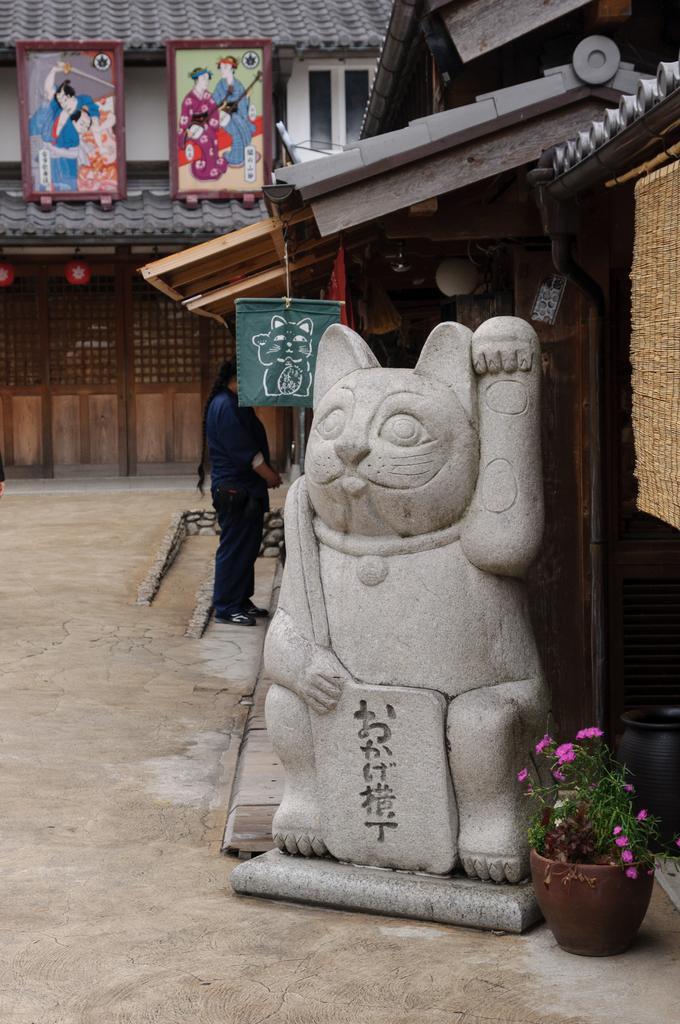Please provide a concise description of this image. This picture is clicked outside. On the right there is a sculpture of an animal and a houseplant placed on the ground and a person standing on the ground. In the background we can see the buildings and posters hanging on the roof on which we can see the pictures of some persons. 